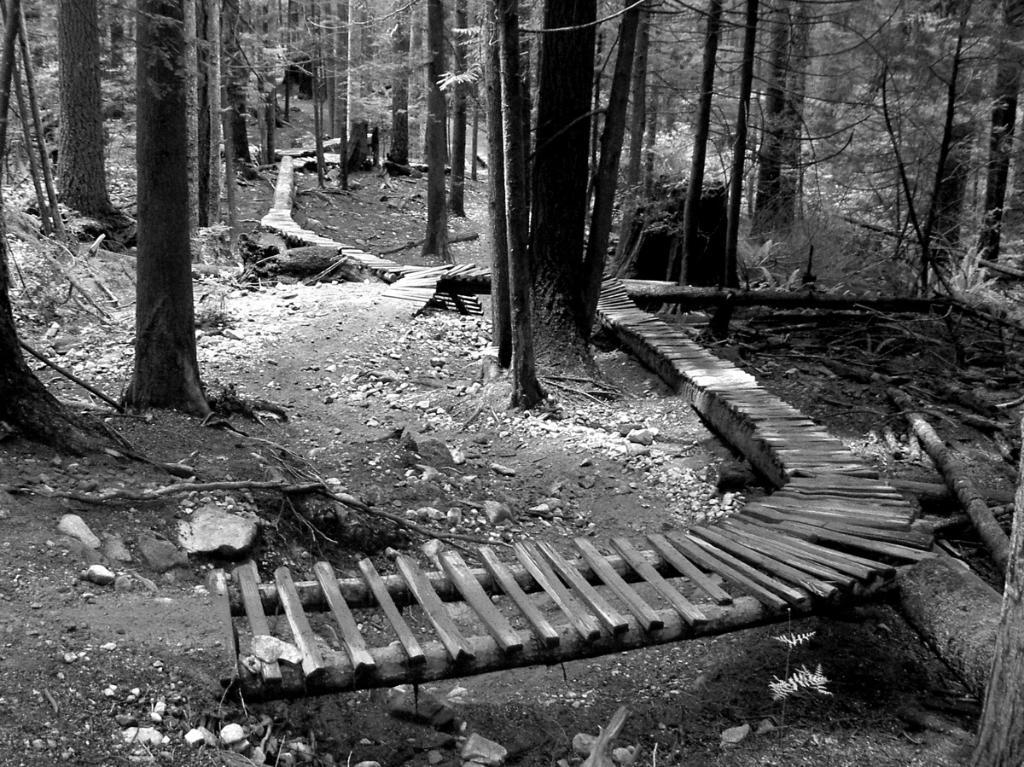In one or two sentences, can you explain what this image depicts? This is a black and white image. I can see the wooden pathway and there are trees. 